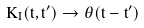<formula> <loc_0><loc_0><loc_500><loc_500>K _ { I } ( t , t ^ { \prime } ) \rightarrow \theta ( t - t ^ { \prime } )</formula> 